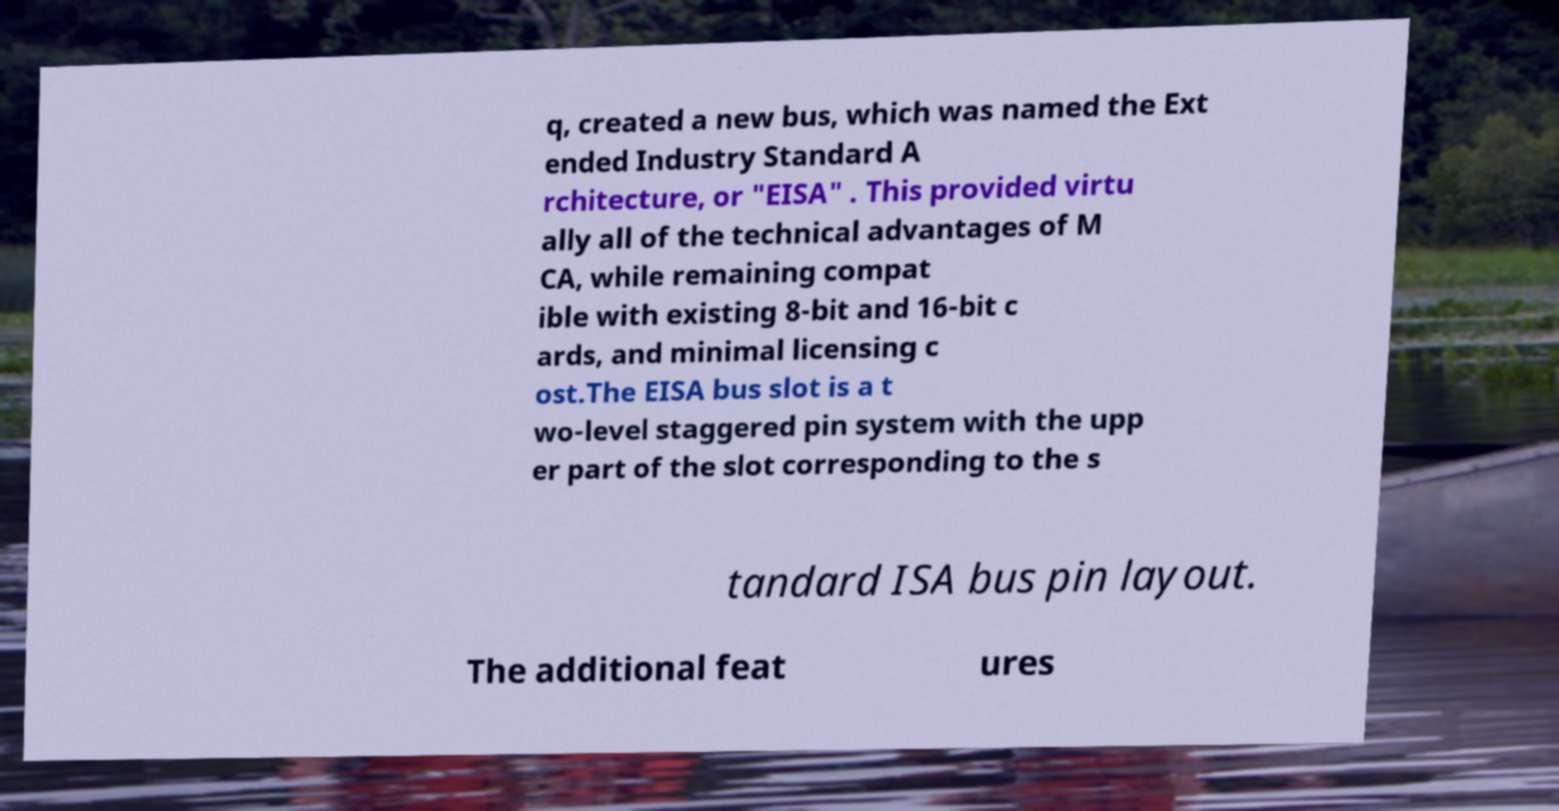Could you extract and type out the text from this image? q, created a new bus, which was named the Ext ended Industry Standard A rchitecture, or "EISA" . This provided virtu ally all of the technical advantages of M CA, while remaining compat ible with existing 8-bit and 16-bit c ards, and minimal licensing c ost.The EISA bus slot is a t wo-level staggered pin system with the upp er part of the slot corresponding to the s tandard ISA bus pin layout. The additional feat ures 